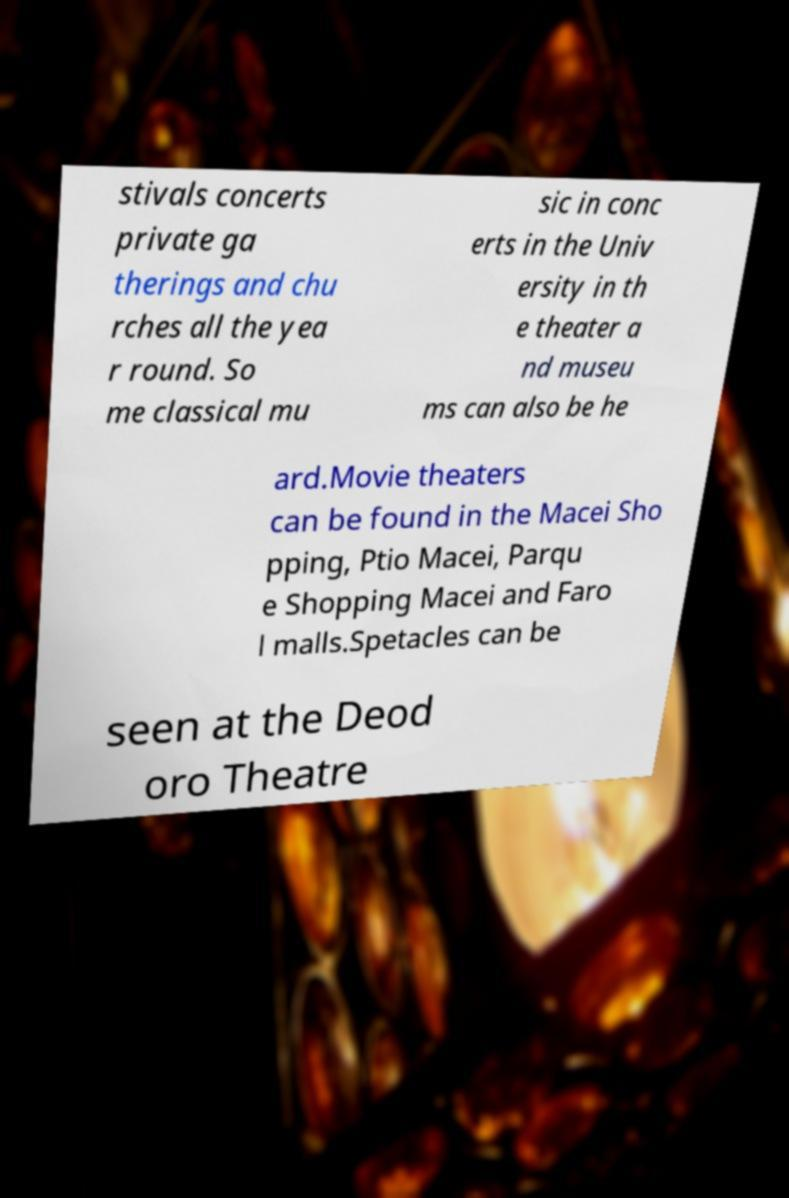For documentation purposes, I need the text within this image transcribed. Could you provide that? stivals concerts private ga therings and chu rches all the yea r round. So me classical mu sic in conc erts in the Univ ersity in th e theater a nd museu ms can also be he ard.Movie theaters can be found in the Macei Sho pping, Ptio Macei, Parqu e Shopping Macei and Faro l malls.Spetacles can be seen at the Deod oro Theatre 